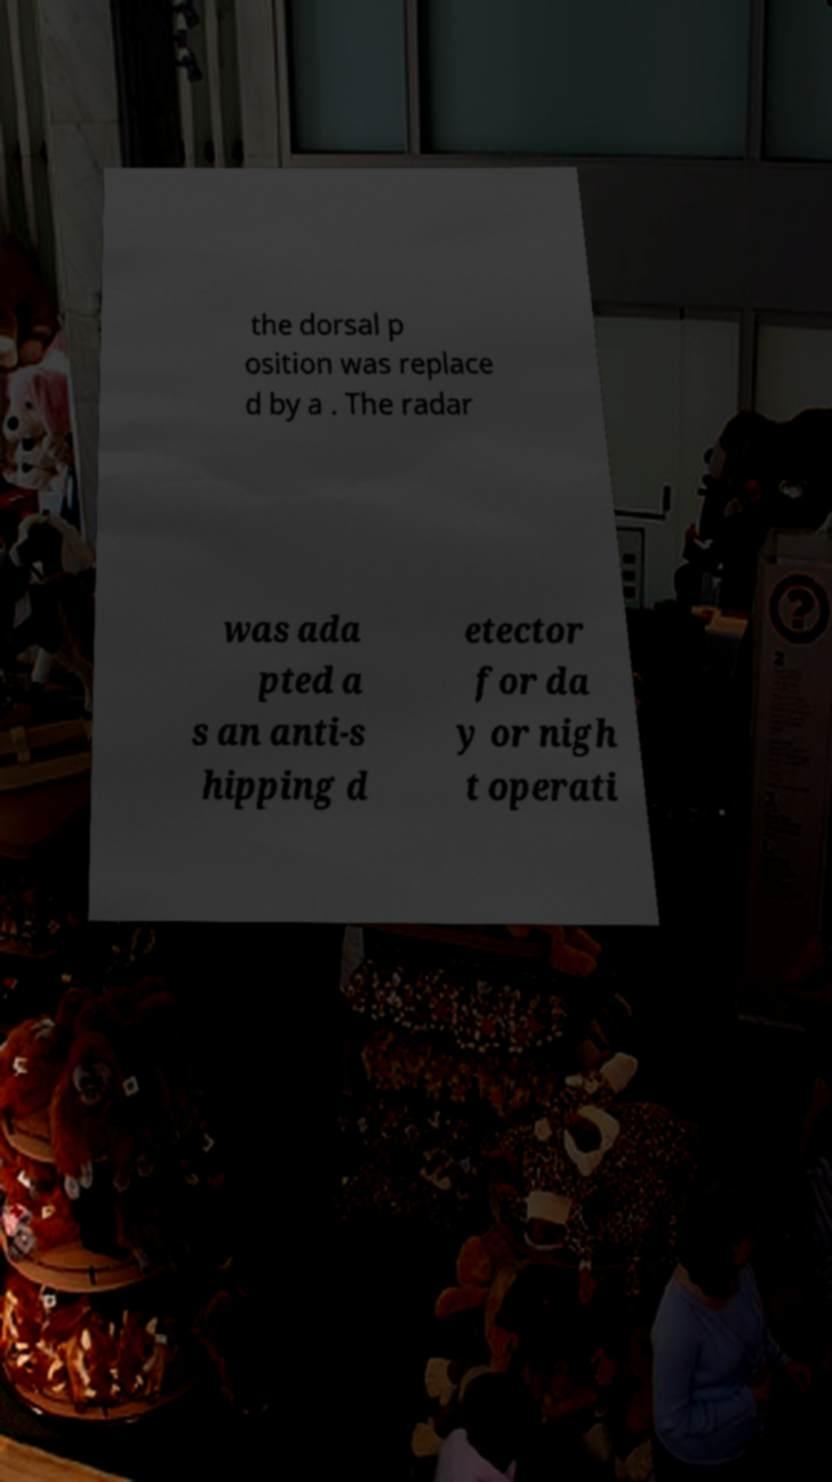Please identify and transcribe the text found in this image. the dorsal p osition was replace d by a . The radar was ada pted a s an anti-s hipping d etector for da y or nigh t operati 